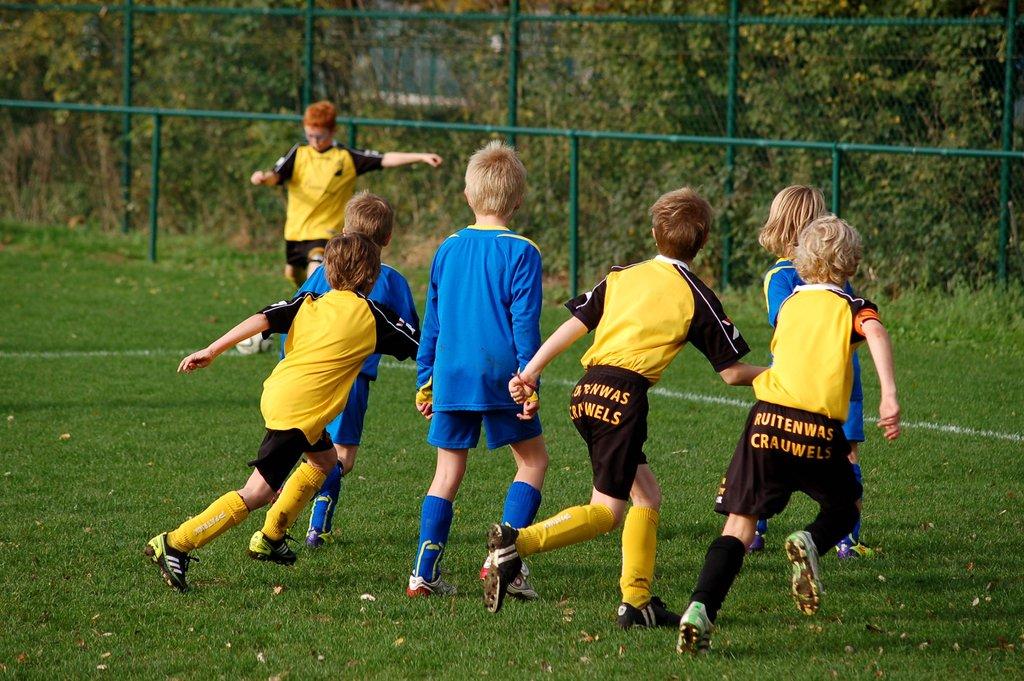What do the boys shorts say?
Ensure brevity in your answer.  Ruitenwas crauwels. What does the text on the furthest right boy's shorts say?
Make the answer very short. Ruitenwas crauwels. 